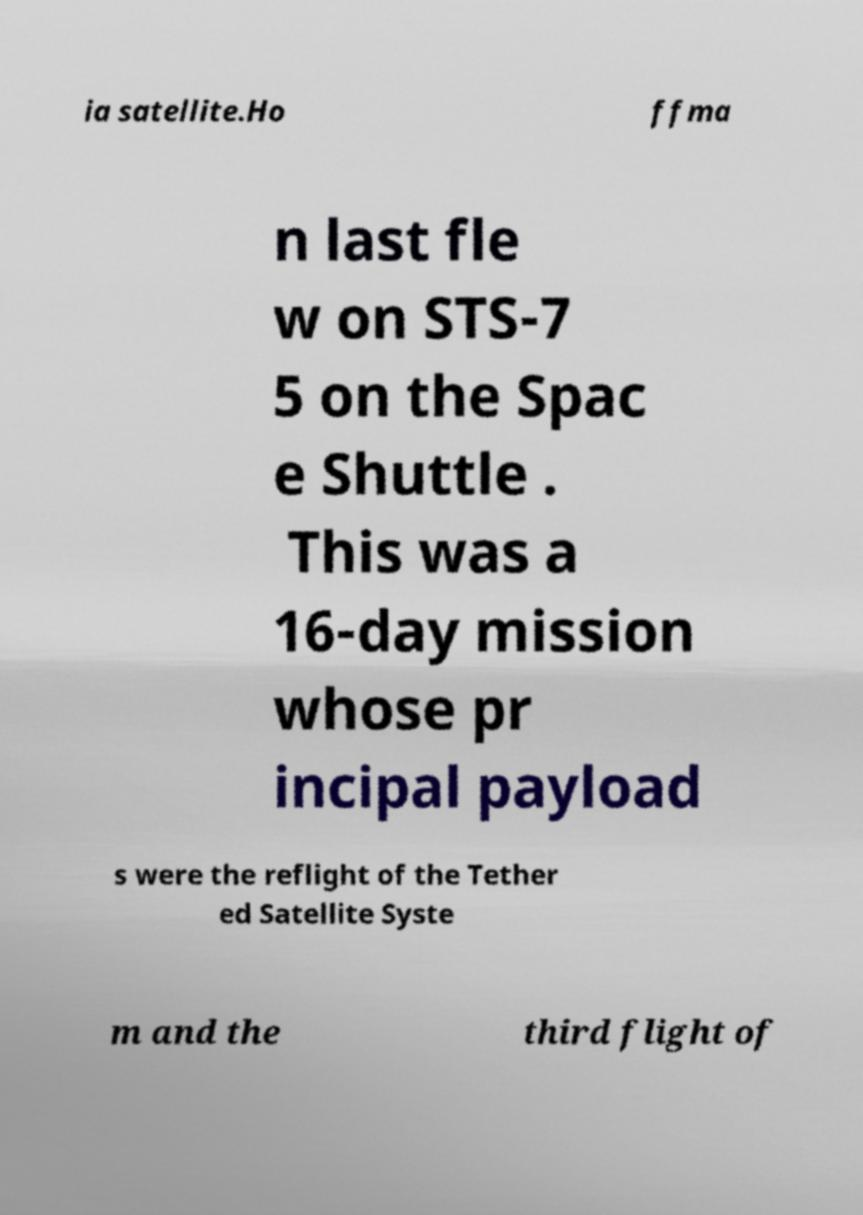For documentation purposes, I need the text within this image transcribed. Could you provide that? ia satellite.Ho ffma n last fle w on STS-7 5 on the Spac e Shuttle . This was a 16-day mission whose pr incipal payload s were the reflight of the Tether ed Satellite Syste m and the third flight of 